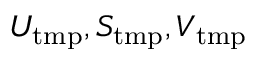Convert formula to latex. <formula><loc_0><loc_0><loc_500><loc_500>U _ { t m p } , S _ { t m p } , V _ { t m p }</formula> 